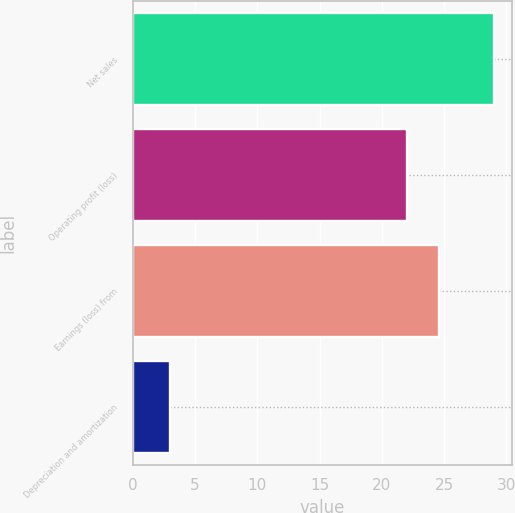Convert chart to OTSL. <chart><loc_0><loc_0><loc_500><loc_500><bar_chart><fcel>Net sales<fcel>Operating profit (loss)<fcel>Earnings (loss) from<fcel>Depreciation and amortization<nl><fcel>29<fcel>22<fcel>24.6<fcel>3<nl></chart> 